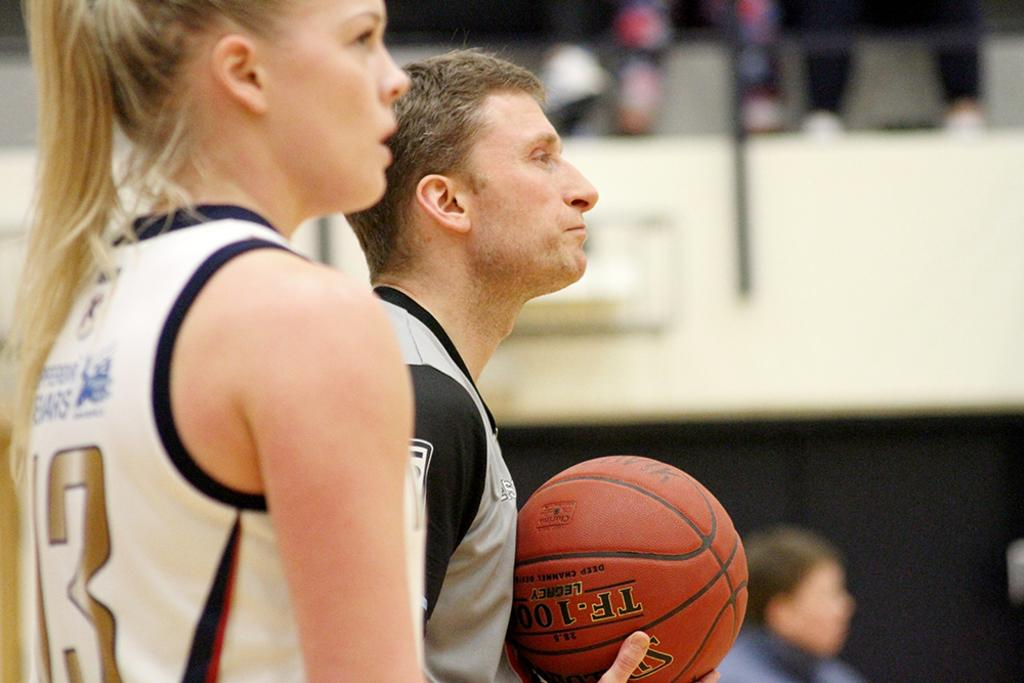Provide a one-sentence caption for the provided image. A basketball in a man's hand has the word legacy on it. 